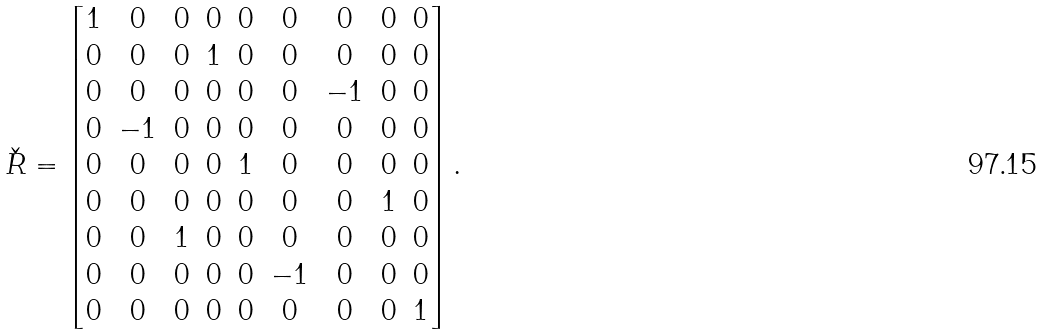<formula> <loc_0><loc_0><loc_500><loc_500>\check { R } = \begin{bmatrix} 1 & 0 & 0 & 0 & 0 & 0 & 0 & 0 & 0 \\ 0 & 0 & 0 & 1 & 0 & 0 & 0 & 0 & 0 \\ 0 & 0 & 0 & 0 & 0 & 0 & - 1 & 0 & 0 \\ 0 & - 1 & 0 & 0 & 0 & 0 & 0 & 0 & 0 \\ 0 & 0 & 0 & 0 & 1 & 0 & 0 & 0 & 0 \\ 0 & 0 & 0 & 0 & 0 & 0 & 0 & 1 & 0 \\ 0 & 0 & 1 & 0 & 0 & 0 & 0 & 0 & 0 \\ 0 & 0 & 0 & 0 & 0 & - 1 & 0 & 0 & 0 \\ 0 & 0 & 0 & 0 & 0 & 0 & 0 & 0 & 1 \end{bmatrix} .</formula> 